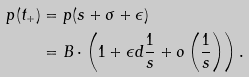<formula> <loc_0><loc_0><loc_500><loc_500>p ( t _ { + } ) & = p ( s + \sigma + \epsilon ) \\ & = B \cdot \left ( 1 + \epsilon d \frac { 1 } { s } + o \left ( \frac { 1 } { s } \right ) \right ) .</formula> 